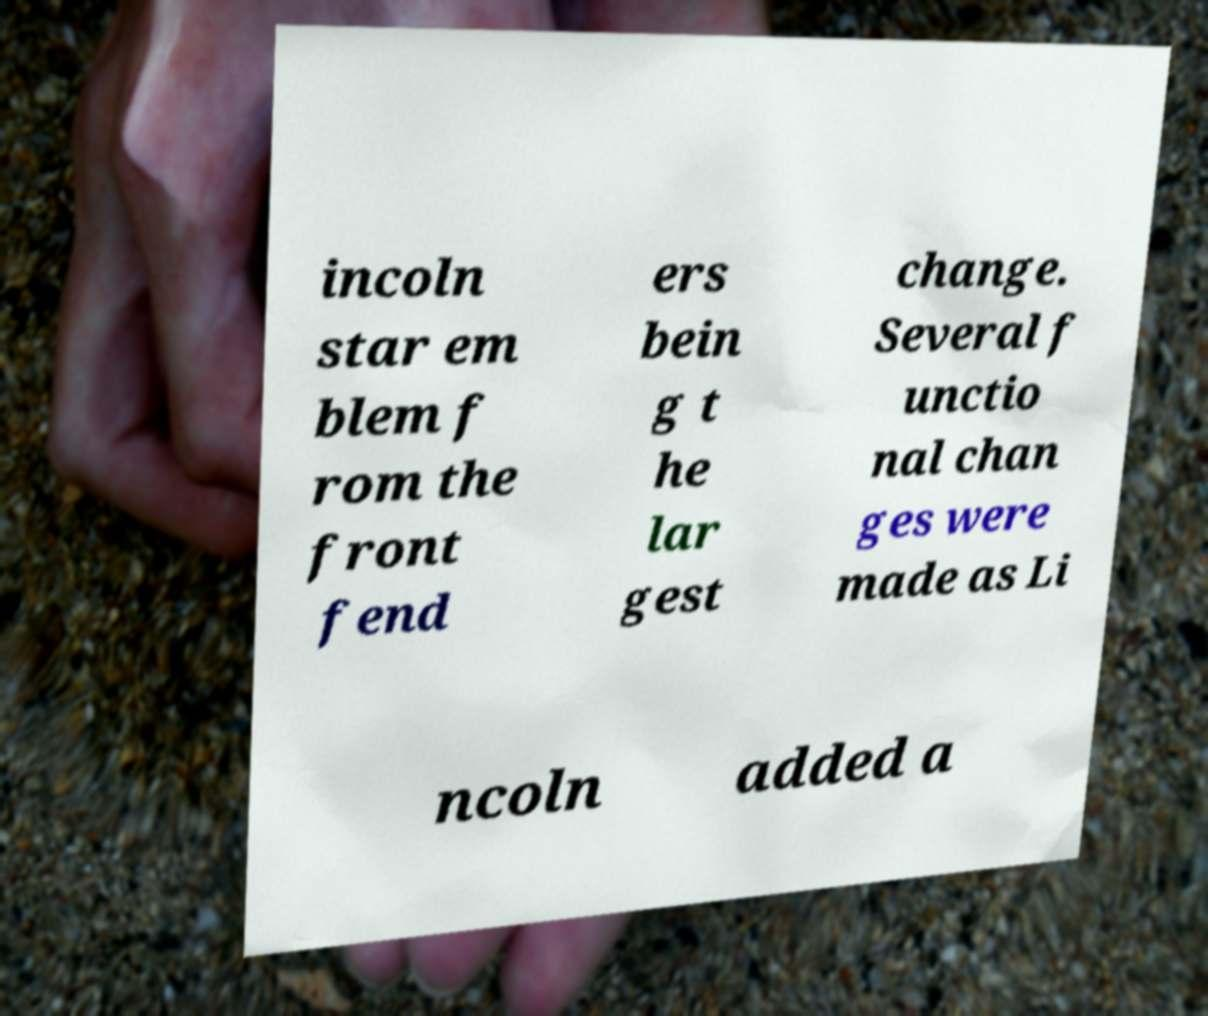Please identify and transcribe the text found in this image. incoln star em blem f rom the front fend ers bein g t he lar gest change. Several f unctio nal chan ges were made as Li ncoln added a 